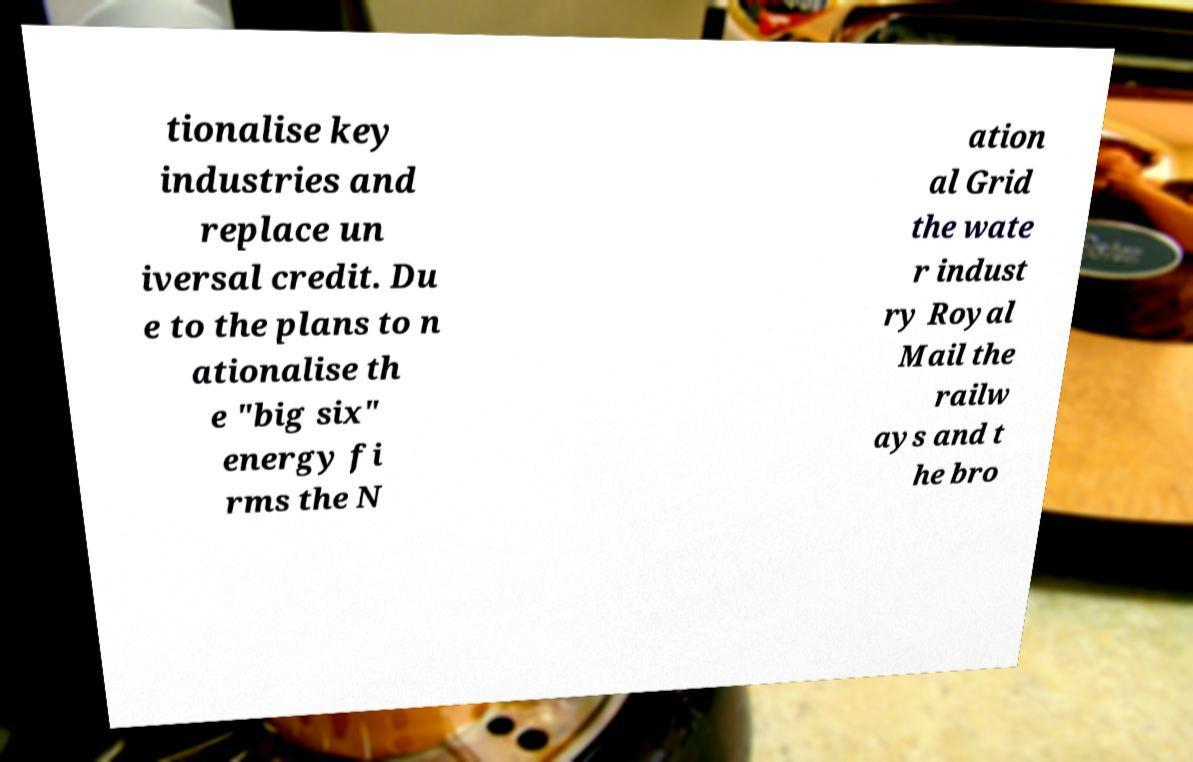I need the written content from this picture converted into text. Can you do that? tionalise key industries and replace un iversal credit. Du e to the plans to n ationalise th e "big six" energy fi rms the N ation al Grid the wate r indust ry Royal Mail the railw ays and t he bro 